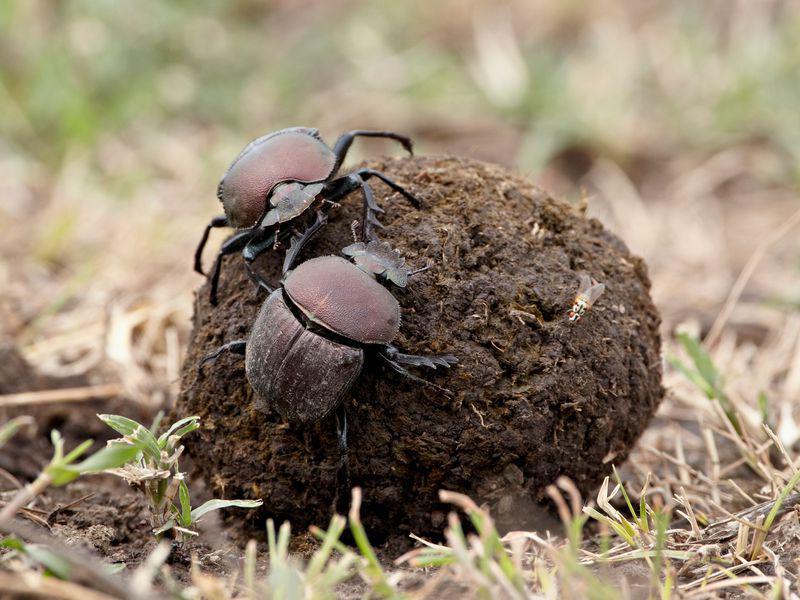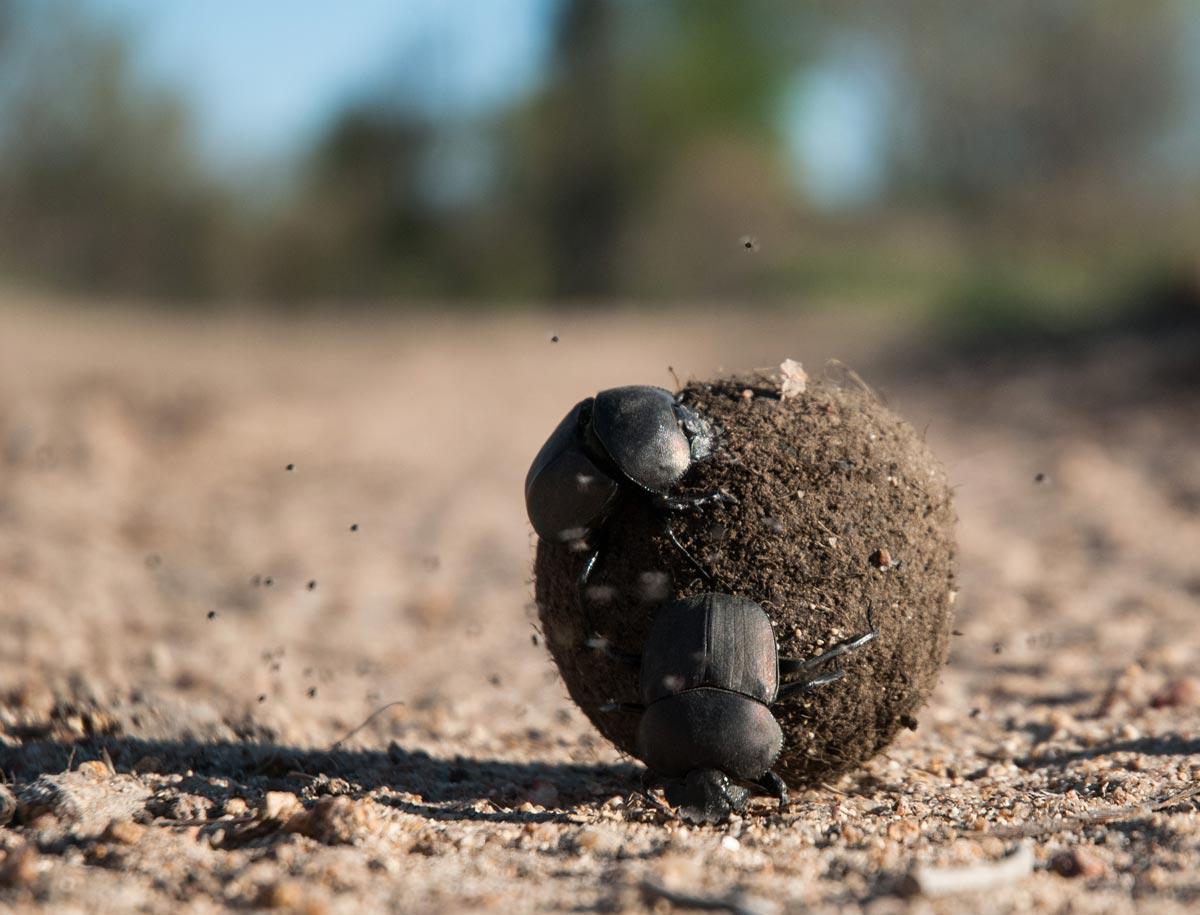The first image is the image on the left, the second image is the image on the right. Given the left and right images, does the statement "One image displays two beetles on the same dung ball." hold true? Answer yes or no. Yes. The first image is the image on the left, the second image is the image on the right. Assess this claim about the two images: "Each image contains a single rounded dung ball, and at least one image contains two beetles.". Correct or not? Answer yes or no. Yes. 